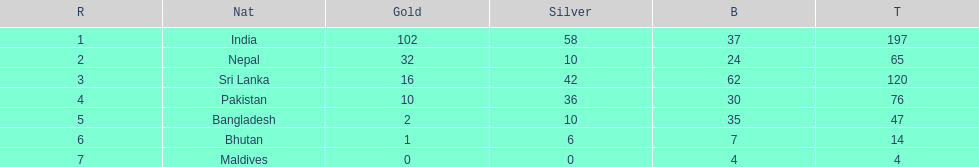What was the only nation to win less than 10 medals total? Maldives. 